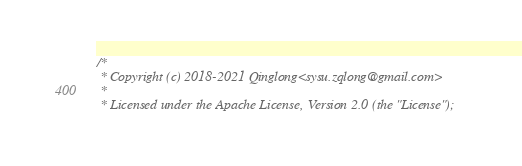Convert code to text. <code><loc_0><loc_0><loc_500><loc_500><_C_>/*
 * Copyright (c) 2018-2021 Qinglong<sysu.zqlong@gmail.com>
 *
 * Licensed under the Apache License, Version 2.0 (the "License");</code> 